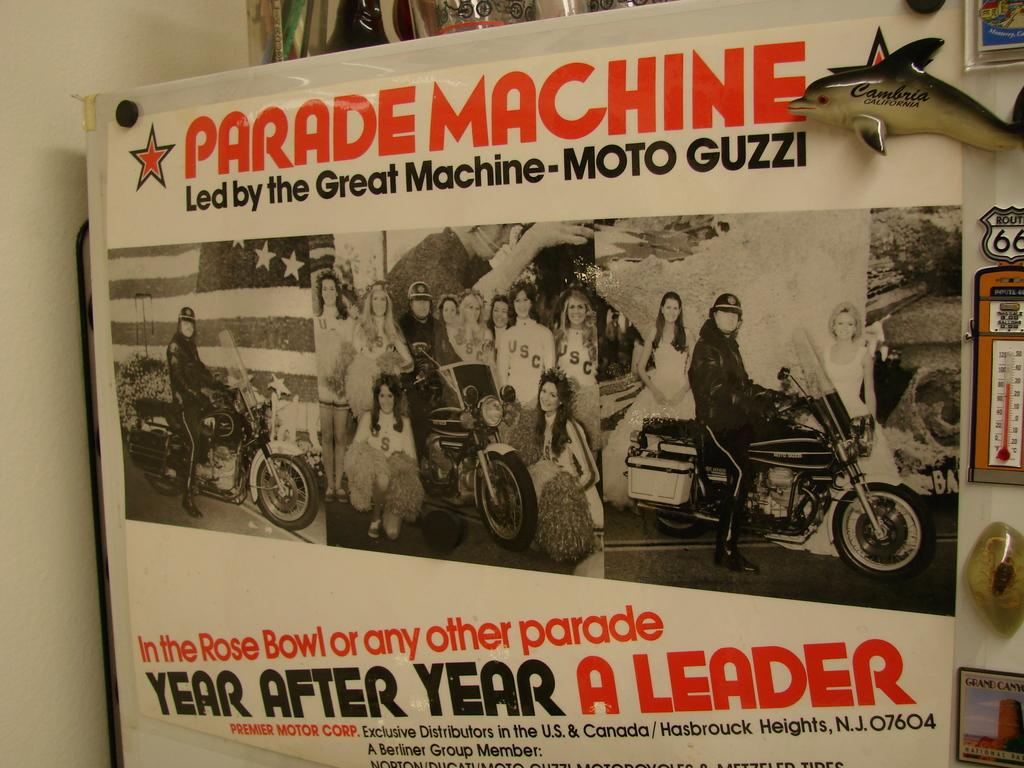<image>
Present a compact description of the photo's key features. A poster placed on the side that title that says Parade Machine Led by the Great Machine Moto Guzzi and people on motorcycles 